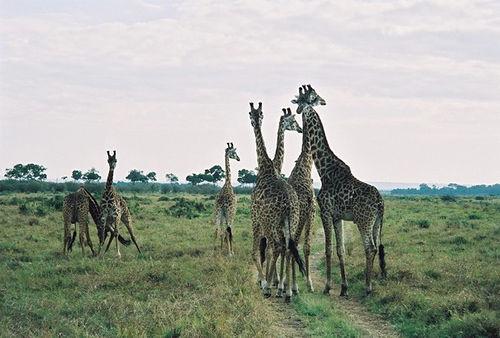What animals are in the field?
Give a very brief answer. Giraffes. How many animals?
Answer briefly. 7. What are these giraffes doing?
Short answer required. Standing. How many giraffe are walking in the grass?
Be succinct. 7. 